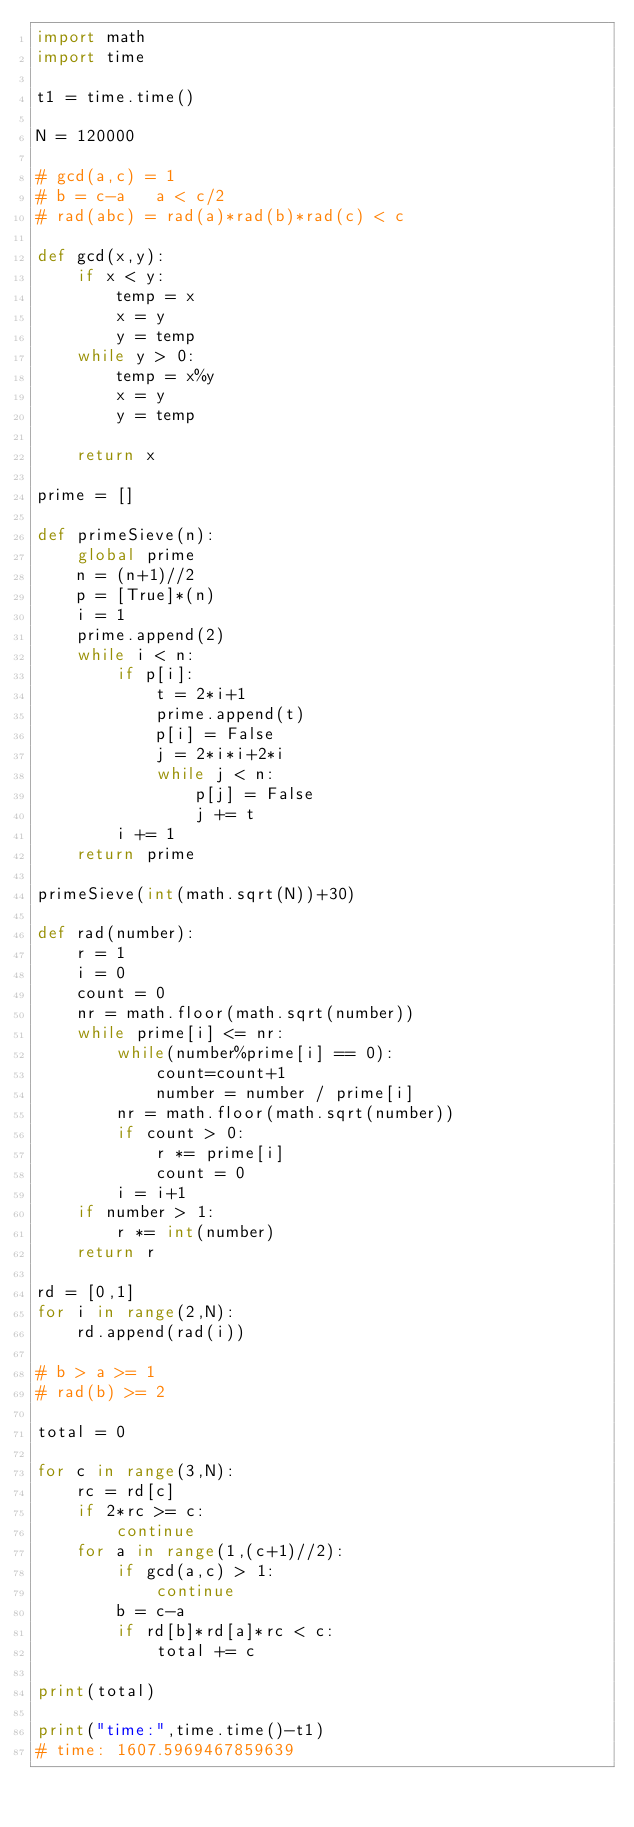<code> <loc_0><loc_0><loc_500><loc_500><_Python_>import math
import time

t1 = time.time()

N = 120000

# gcd(a,c) = 1
# b = c-a   a < c/2
# rad(abc) = rad(a)*rad(b)*rad(c) < c

def gcd(x,y):
    if x < y:
        temp = x
        x = y
        y = temp
    while y > 0:
        temp = x%y
        x = y
        y = temp

    return x

prime = []

def primeSieve(n):
    global prime
    n = (n+1)//2
    p = [True]*(n)
    i = 1
    prime.append(2)
    while i < n:
        if p[i]:
            t = 2*i+1
            prime.append(t)
            p[i] = False
            j = 2*i*i+2*i
            while j < n:
                p[j] = False
                j += t
        i += 1
    return prime

primeSieve(int(math.sqrt(N))+30)

def rad(number):
    r = 1
    i = 0
    count = 0
    nr = math.floor(math.sqrt(number))
    while prime[i] <= nr:
        while(number%prime[i] == 0):
            count=count+1
            number = number / prime[i]
        nr = math.floor(math.sqrt(number)) 
        if count > 0:
            r *= prime[i]
            count = 0 
        i = i+1
    if number > 1:
        r *= int(number)
    return r

rd = [0,1]
for i in range(2,N):
    rd.append(rad(i))

# b > a >= 1
# rad(b) >= 2

total = 0

for c in range(3,N):
    rc = rd[c]
    if 2*rc >= c:
        continue
    for a in range(1,(c+1)//2):
        if gcd(a,c) > 1:
            continue
        b = c-a
        if rd[b]*rd[a]*rc < c:
            total += c

print(total)    

print("time:",time.time()-t1)  
# time: 1607.5969467859639

    
</code> 